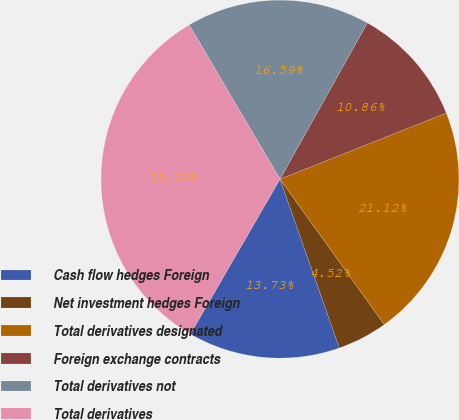<chart> <loc_0><loc_0><loc_500><loc_500><pie_chart><fcel>Cash flow hedges Foreign<fcel>Net investment hedges Foreign<fcel>Total derivatives designated<fcel>Foreign exchange contracts<fcel>Total derivatives not<fcel>Total derivatives<nl><fcel>13.73%<fcel>4.52%<fcel>21.12%<fcel>10.86%<fcel>16.59%<fcel>33.18%<nl></chart> 